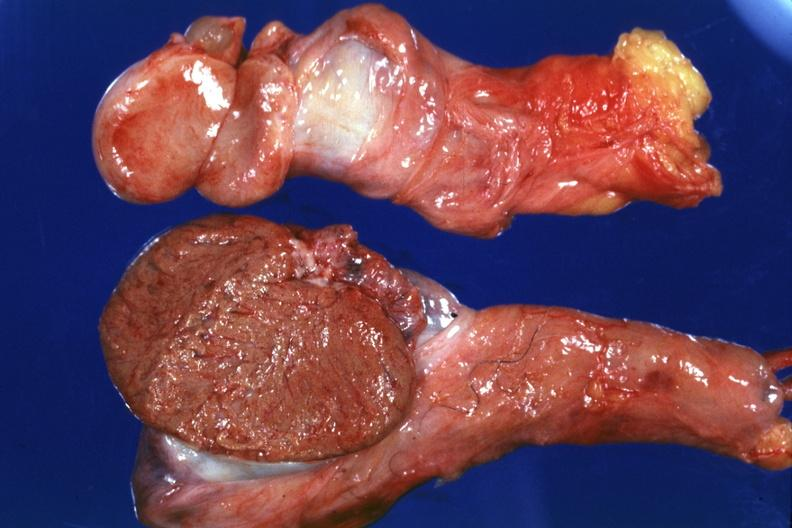what do cut surface both testicles on normal and one quite small typical probably due to mumps have?
Answer the question using a single word or phrase. Cut 